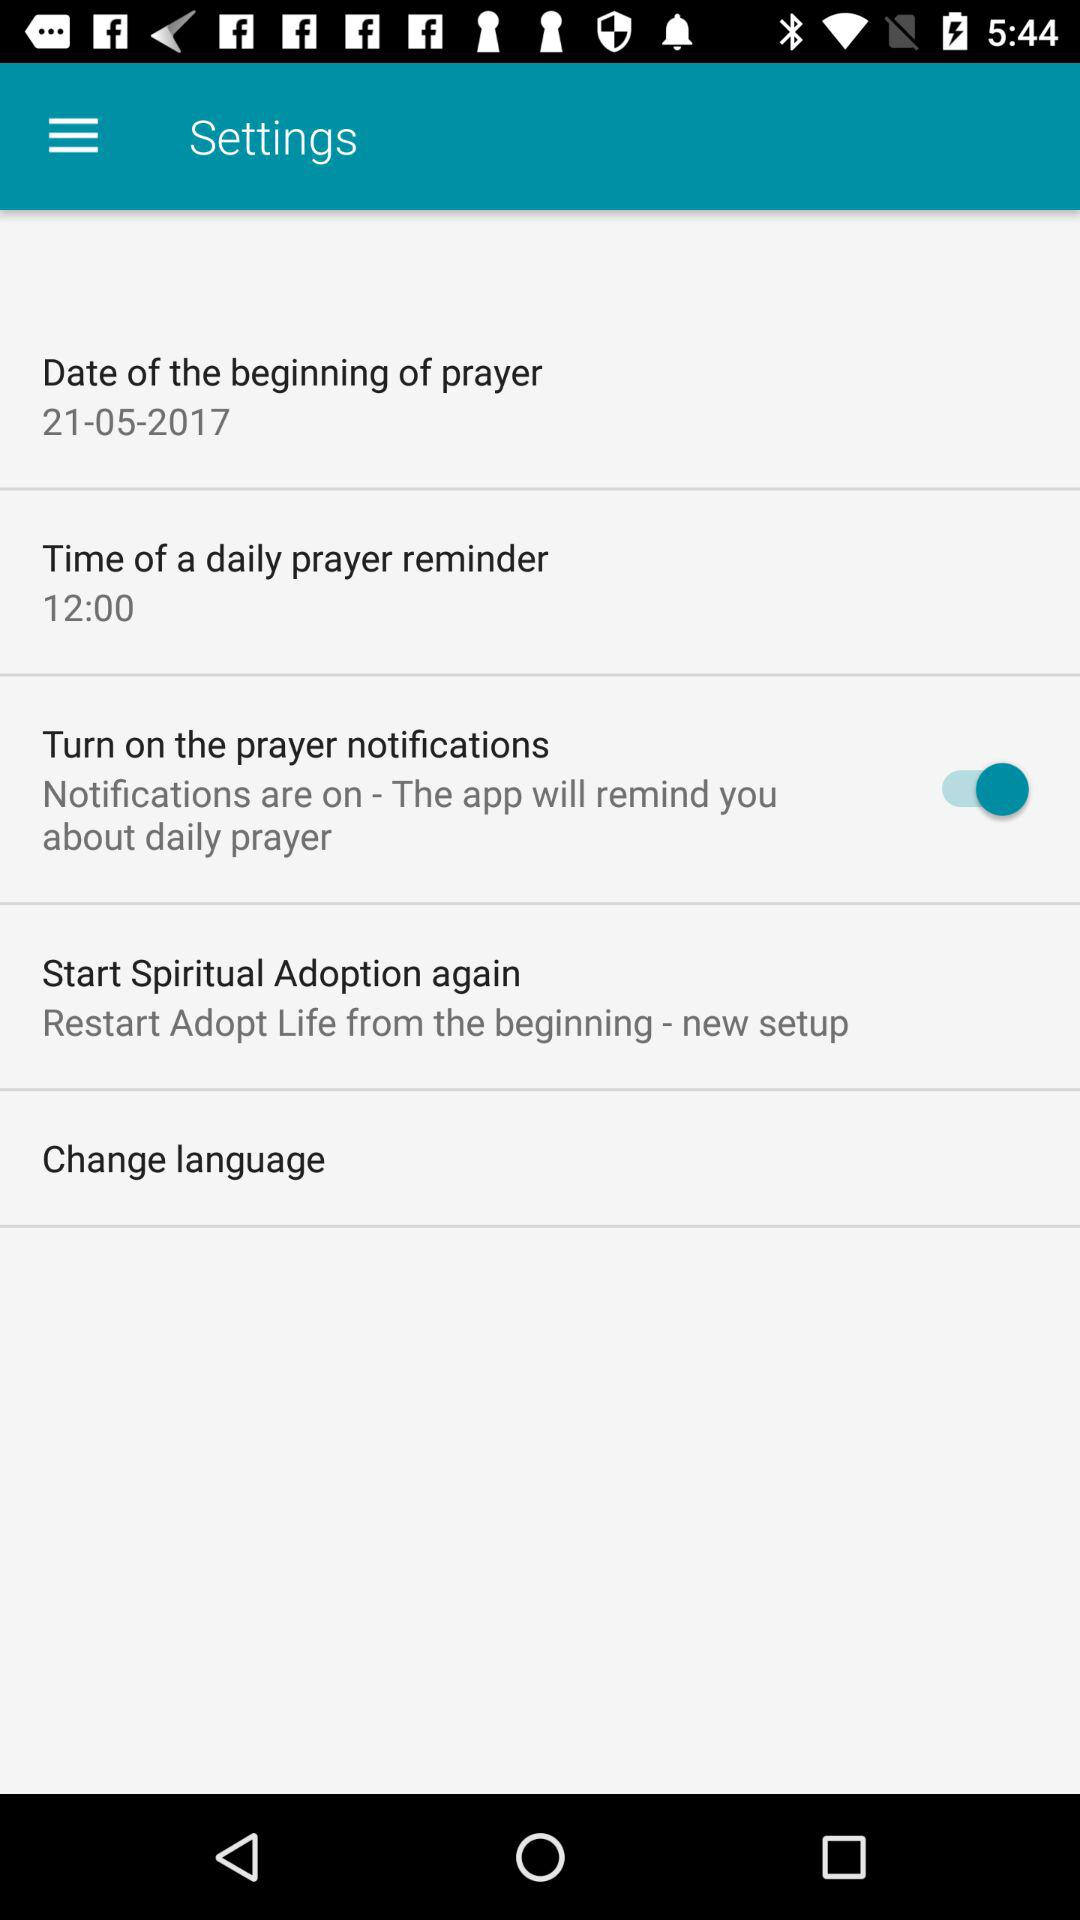What is the status of the "Turn on the prayer notifications"? The status is "on". 